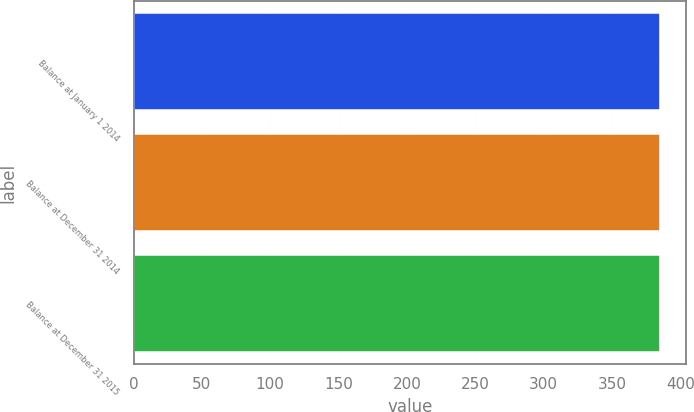Convert chart to OTSL. <chart><loc_0><loc_0><loc_500><loc_500><bar_chart><fcel>Balance at January 1 2014<fcel>Balance at December 31 2014<fcel>Balance at December 31 2015<nl><fcel>385<fcel>385.1<fcel>385.2<nl></chart> 